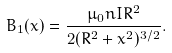Convert formula to latex. <formula><loc_0><loc_0><loc_500><loc_500>B _ { 1 } ( x ) = { \frac { \mu _ { 0 } n I R ^ { 2 } } { 2 ( R ^ { 2 } + x ^ { 2 } ) ^ { 3 / 2 } } } .</formula> 